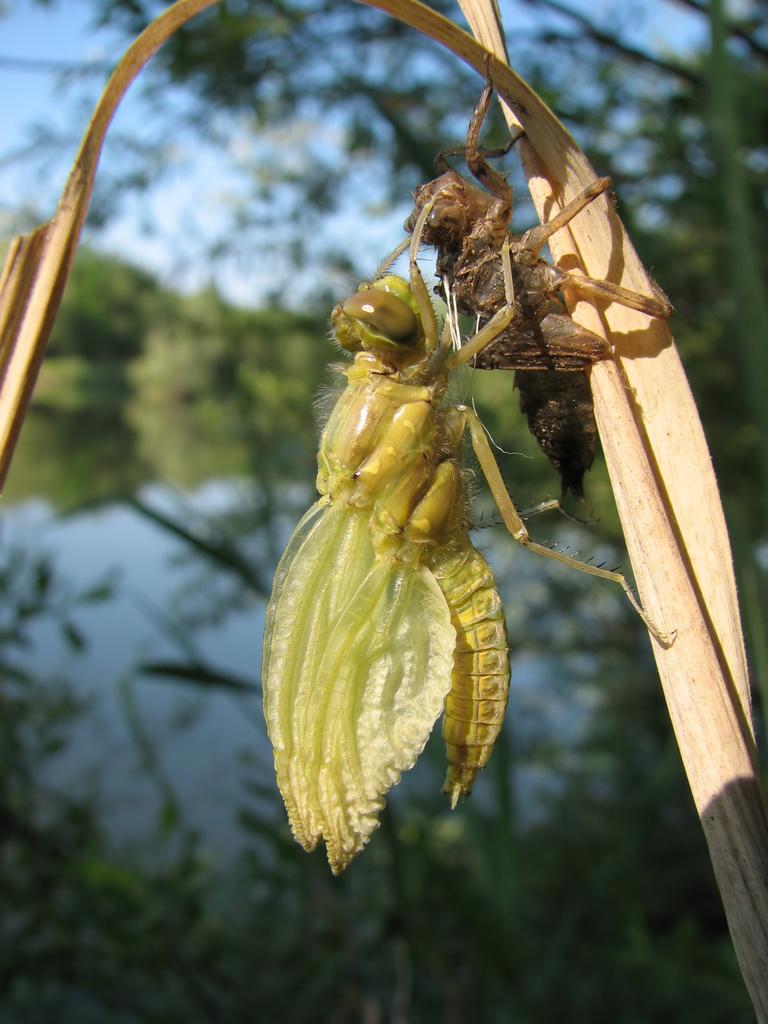How would you summarize this image in a sentence or two? In this image I see 2 insects which are of brown and green in color and these 2 insects are on this thing and I see that it is a bit green and blue in the background. 